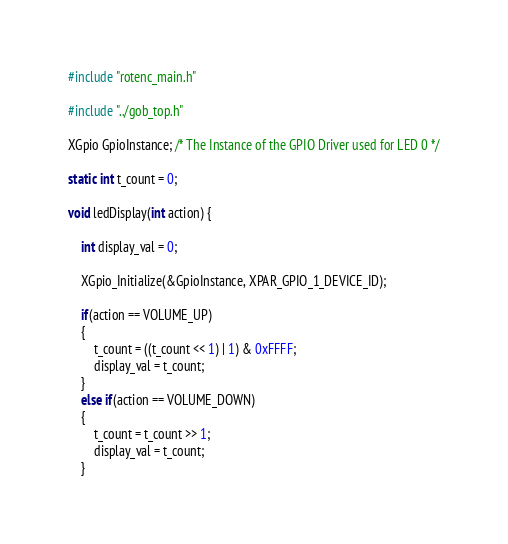Convert code to text. <code><loc_0><loc_0><loc_500><loc_500><_C_>#include "rotenc_main.h"

#include "../gob_top.h"

XGpio GpioInstance; /* The Instance of the GPIO Driver used for LED 0 */

static int t_count = 0;

void ledDisplay(int action) {

	int display_val = 0;

	XGpio_Initialize(&GpioInstance, XPAR_GPIO_1_DEVICE_ID);

	if(action == VOLUME_UP)
	{
		t_count = ((t_count << 1) | 1) & 0xFFFF;
		display_val = t_count;
	}
	else if(action == VOLUME_DOWN)
	{
		t_count = t_count >> 1;
		display_val = t_count;
	}</code> 